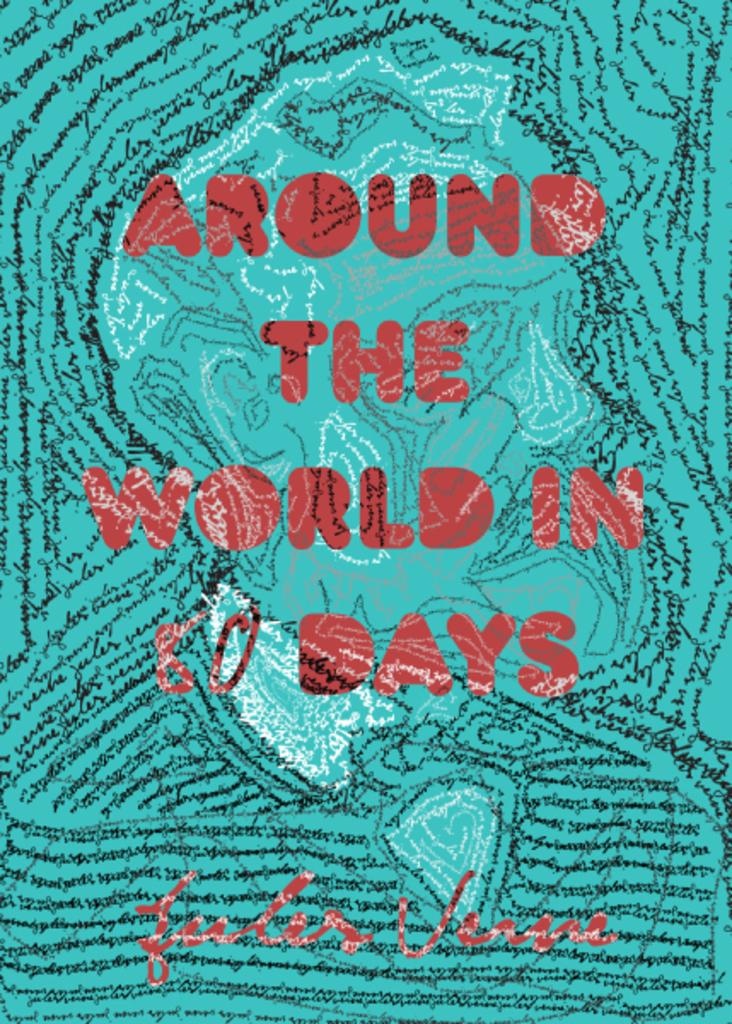<image>
Create a compact narrative representing the image presented. The book cover for Around the World in 80 Days. 